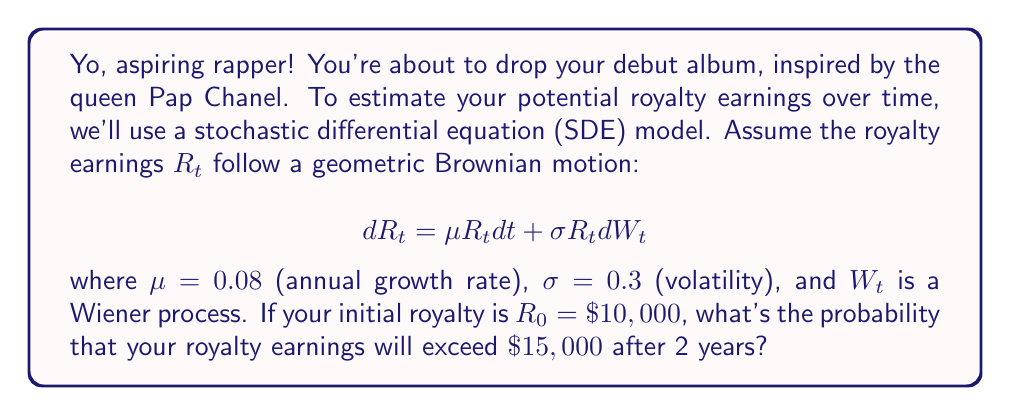Teach me how to tackle this problem. Let's break this down step-by-step:

1) For geometric Brownian motion, the solution to the SDE is:

   $$ R_t = R_0 \exp\left(\left(\mu - \frac{\sigma^2}{2}\right)t + \sigma W_t\right) $$

2) $\ln(R_t)$ follows a normal distribution with:
   
   Mean: $\ln(R_0) + \left(\mu - \frac{\sigma^2}{2}\right)t$
   Variance: $\sigma^2 t$

3) We want to find $P(R_2 > 15000)$, which is equivalent to:
   
   $P(\ln(R_2) > \ln(15000))$

4) Let's calculate the mean and variance for $\ln(R_2)$:

   Mean: $\ln(10000) + (0.08 - \frac{0.3^2}{2})2 = 9.21 + 0.07 = 9.28$
   Variance: $0.3^2 \cdot 2 = 0.18$

5) Now we can standardize:

   $$ Z = \frac{\ln(15000) - 9.28}{\sqrt{0.18}} = \frac{9.62 - 9.28}{0.42} = 0.81 $$

6) We want $P(Z > 0.81)$, which is $1 - \Phi(0.81)$, where $\Phi$ is the standard normal CDF.

7) Using a standard normal table or calculator, we find:

   $1 - \Phi(0.81) \approx 0.2090$

Therefore, the probability that your royalty earnings will exceed $15,000 after 2 years is approximately 0.2090 or 20.90%.
Answer: 0.2090 (or 20.90%) 